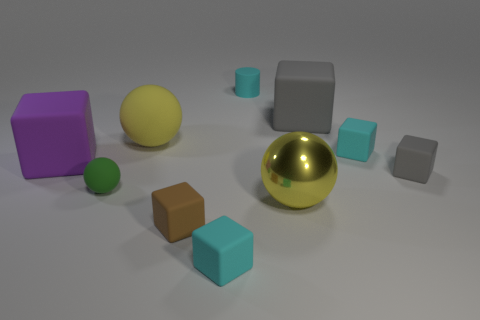What shape is the gray object to the left of the small cyan matte block that is on the right side of the tiny cylinder? The gray object to the left of the small cyan matte block, which is situated to the right side of the tiny green cylinder, is a cube. This cube showcases six faces, all with equal dimensions, indicative of a standard geometric cube. 